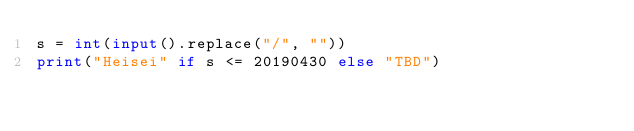Convert code to text. <code><loc_0><loc_0><loc_500><loc_500><_Python_>s = int(input().replace("/", ""))
print("Heisei" if s <= 20190430 else "TBD")</code> 